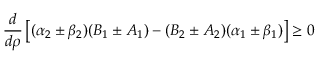<formula> <loc_0><loc_0><loc_500><loc_500>\frac { d } { d \rho } \left [ ( \alpha _ { 2 } \pm \beta _ { 2 } ) ( B _ { 1 } \pm A _ { 1 } ) - ( B _ { 2 } \pm A _ { 2 } ) ( \alpha _ { 1 } \pm \beta _ { 1 } ) \right ] \geq 0</formula> 